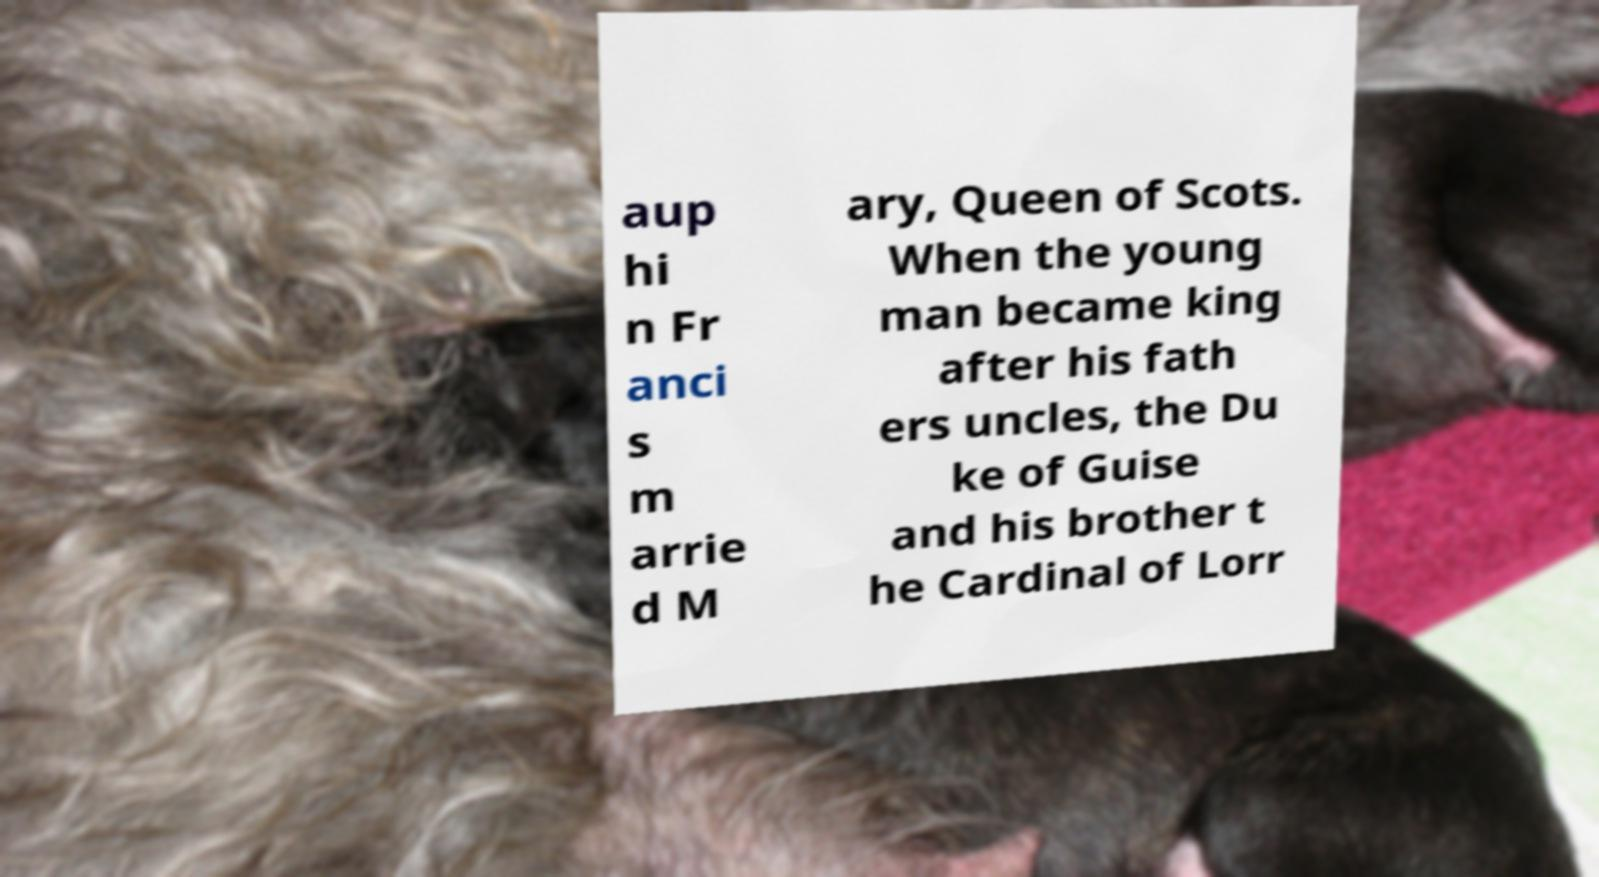There's text embedded in this image that I need extracted. Can you transcribe it verbatim? aup hi n Fr anci s m arrie d M ary, Queen of Scots. When the young man became king after his fath ers uncles, the Du ke of Guise and his brother t he Cardinal of Lorr 